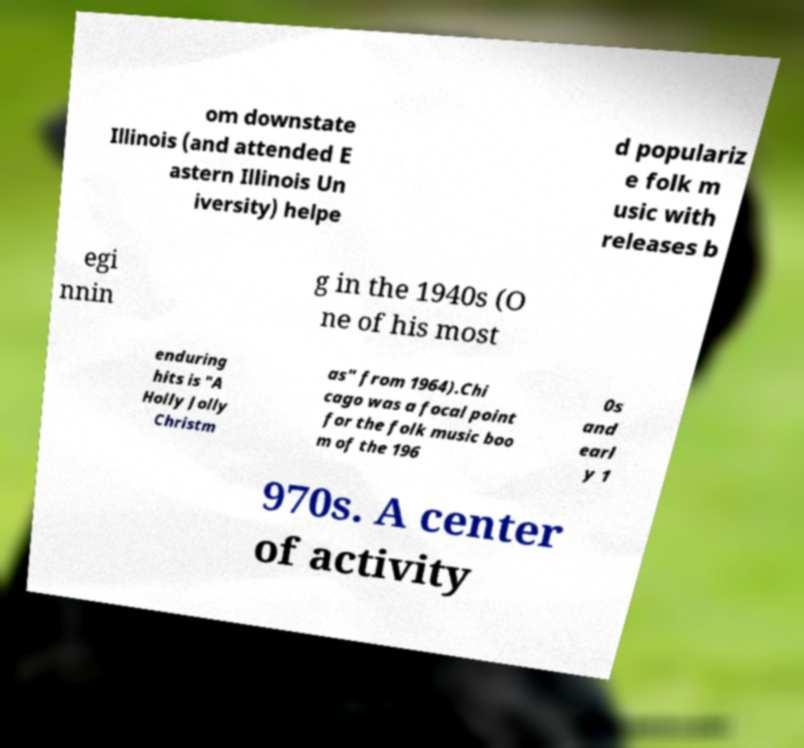Can you accurately transcribe the text from the provided image for me? om downstate Illinois (and attended E astern Illinois Un iversity) helpe d populariz e folk m usic with releases b egi nnin g in the 1940s (O ne of his most enduring hits is "A Holly Jolly Christm as" from 1964).Chi cago was a focal point for the folk music boo m of the 196 0s and earl y 1 970s. A center of activity 